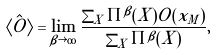<formula> <loc_0><loc_0><loc_500><loc_500>\langle \hat { O } \rangle = \lim _ { \beta \rightarrow \infty } \frac { \sum _ { X } \Pi ^ { \beta } ( X ) O ( x _ { M } ) } { \sum _ { X } \Pi ^ { \beta } ( X ) } ,</formula> 